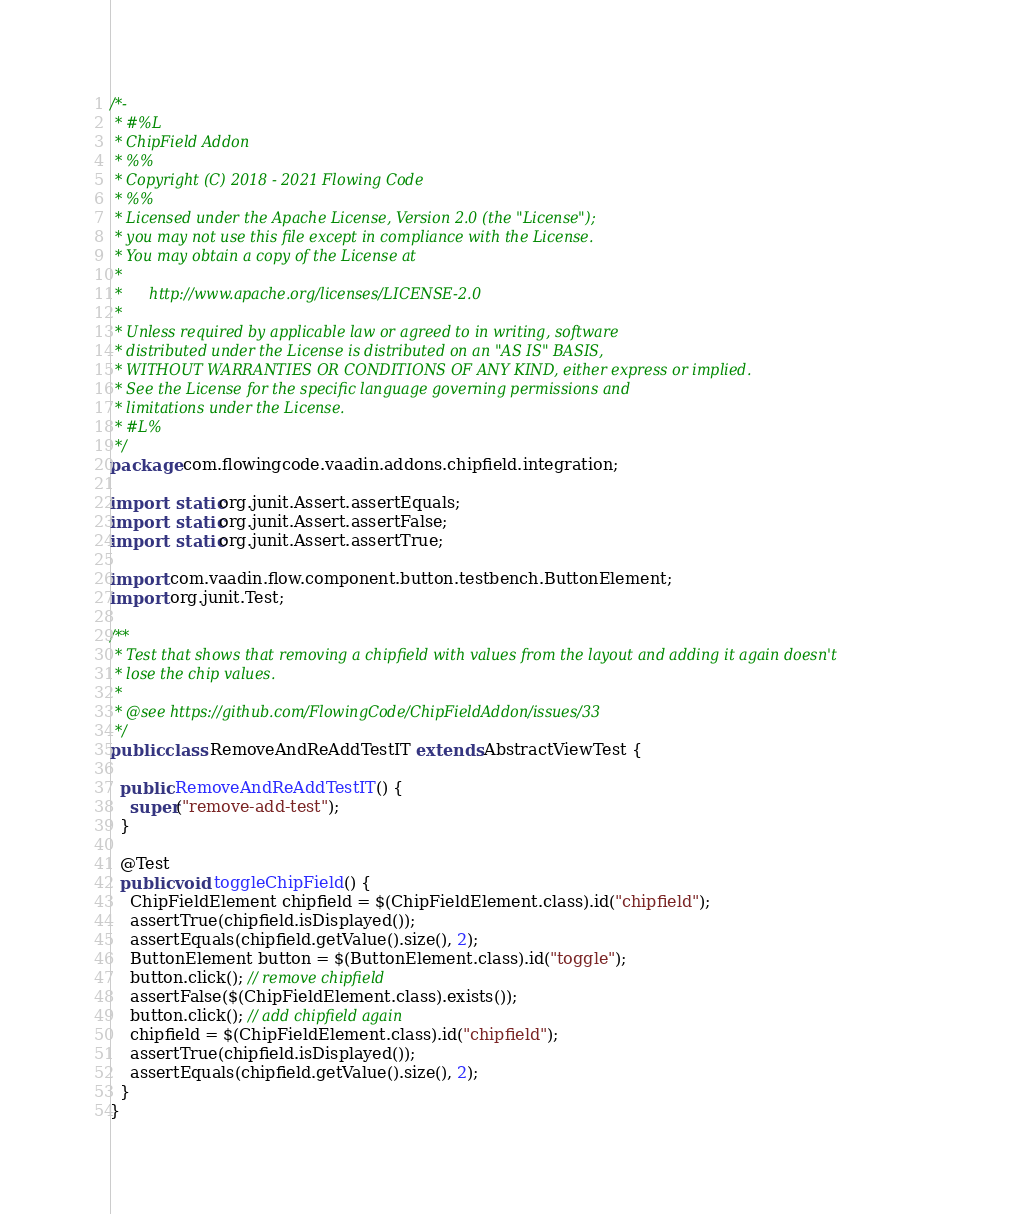<code> <loc_0><loc_0><loc_500><loc_500><_Java_>/*-
 * #%L
 * ChipField Addon
 * %%
 * Copyright (C) 2018 - 2021 Flowing Code
 * %%
 * Licensed under the Apache License, Version 2.0 (the "License");
 * you may not use this file except in compliance with the License.
 * You may obtain a copy of the License at
 *
 *      http://www.apache.org/licenses/LICENSE-2.0
 *
 * Unless required by applicable law or agreed to in writing, software
 * distributed under the License is distributed on an "AS IS" BASIS,
 * WITHOUT WARRANTIES OR CONDITIONS OF ANY KIND, either express or implied.
 * See the License for the specific language governing permissions and
 * limitations under the License.
 * #L%
 */
package com.flowingcode.vaadin.addons.chipfield.integration;

import static org.junit.Assert.assertEquals;
import static org.junit.Assert.assertFalse;
import static org.junit.Assert.assertTrue;

import com.vaadin.flow.component.button.testbench.ButtonElement;
import org.junit.Test;

/**
 * Test that shows that removing a chipfield with values from the layout and adding it again doesn't
 * lose the chip values.
 *
 * @see https://github.com/FlowingCode/ChipFieldAddon/issues/33
 */
public class RemoveAndReAddTestIT extends AbstractViewTest {

  public RemoveAndReAddTestIT() {
    super("remove-add-test");
  }

  @Test
  public void toggleChipField() {
    ChipFieldElement chipfield = $(ChipFieldElement.class).id("chipfield");
    assertTrue(chipfield.isDisplayed());
    assertEquals(chipfield.getValue().size(), 2);
    ButtonElement button = $(ButtonElement.class).id("toggle");
    button.click(); // remove chipfield
    assertFalse($(ChipFieldElement.class).exists());
    button.click(); // add chipfield again
    chipfield = $(ChipFieldElement.class).id("chipfield");
    assertTrue(chipfield.isDisplayed());
    assertEquals(chipfield.getValue().size(), 2);
  }
}
</code> 